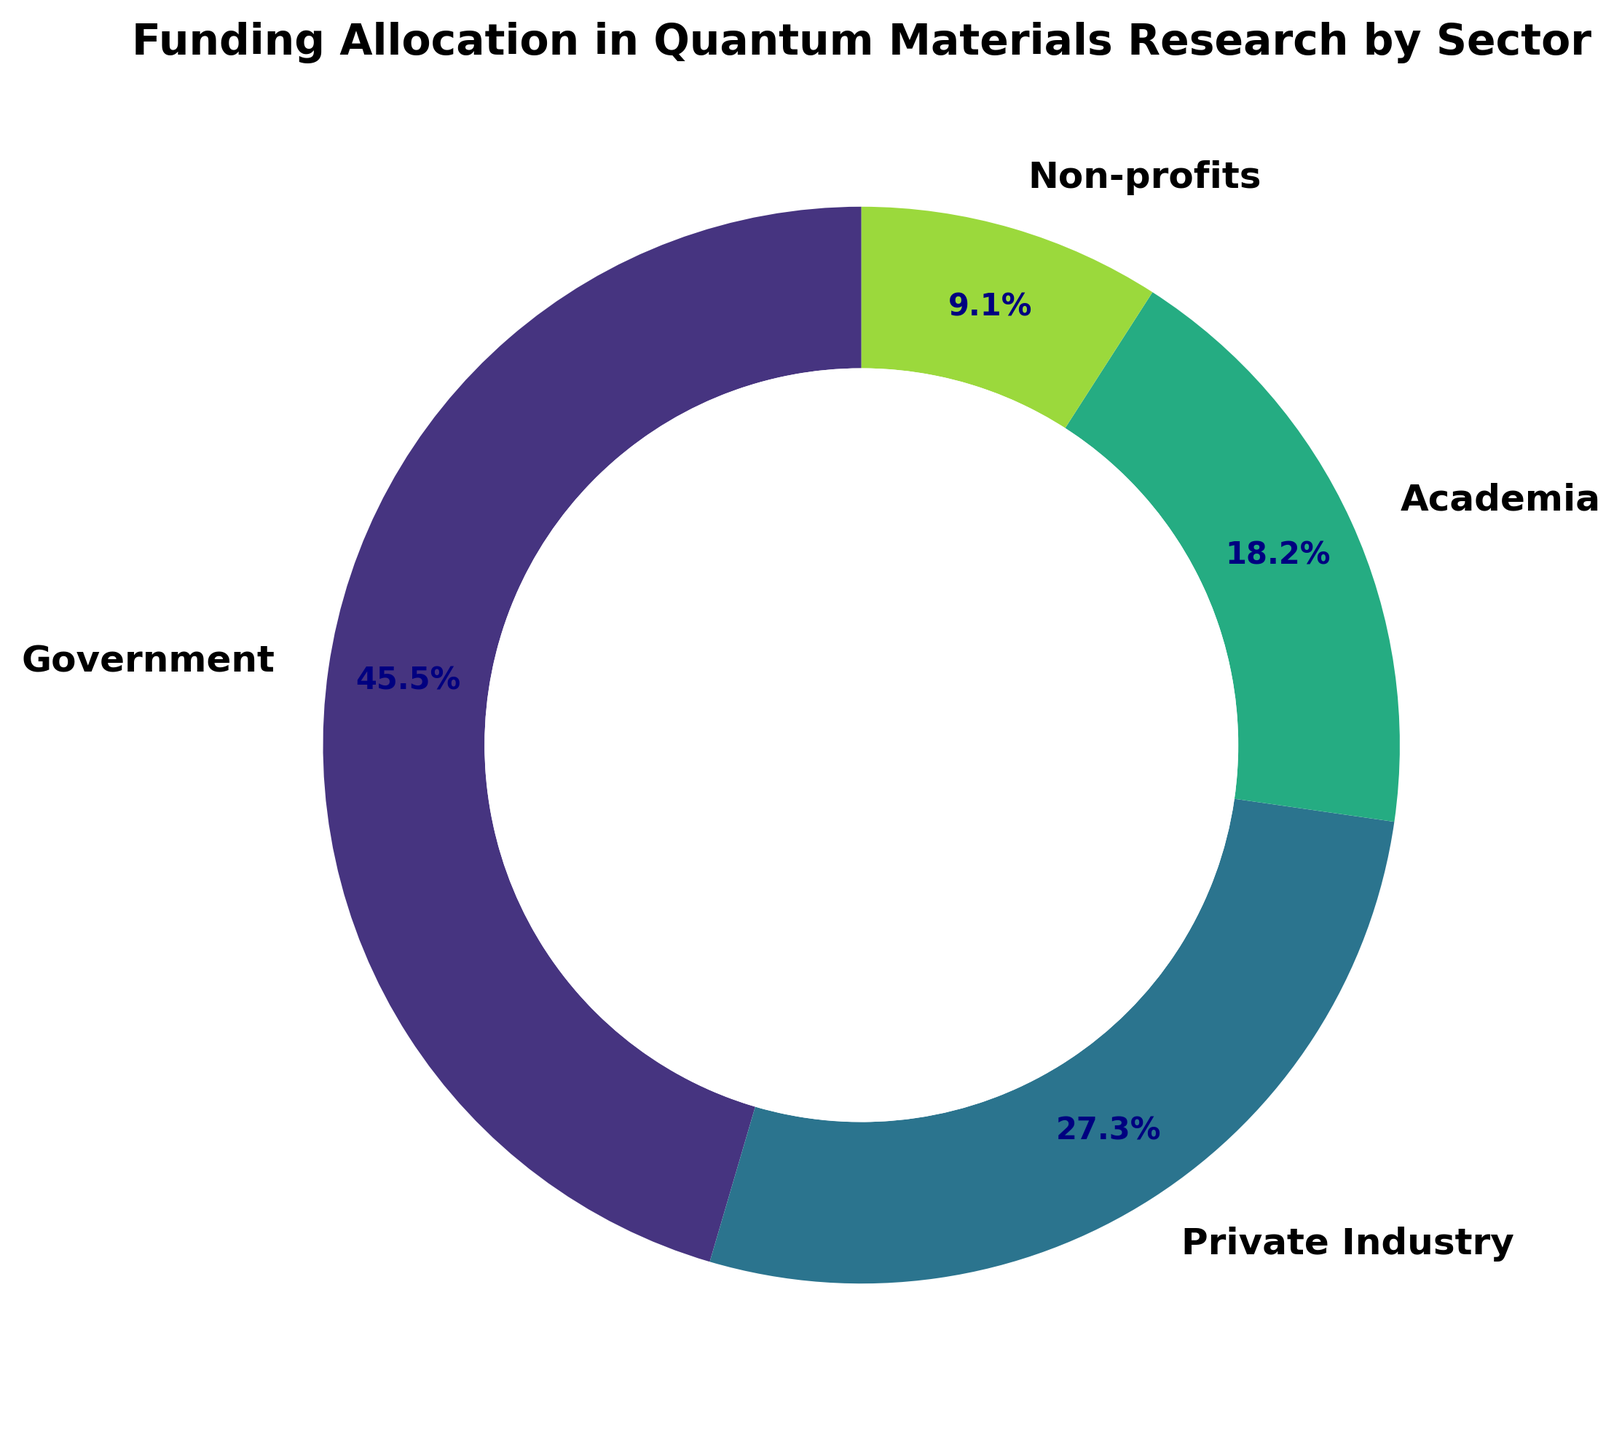Which sector receives the largest funding? The figure shows that the segment labeled "Government" is the largest in size and is annotated with the largest percentage, indicating it receives the largest funding amount.
Answer: Government How much more funding does the Government sector receive compared to the Private Industry sector? The funding for the Government sector is $250 million, and the funding for the Private Industry sector is $150 million. The difference is $250 million - $150 million = $100 million.
Answer: $100 million Which sector has the smallest funding allocation? The smallest segment in the figure is labeled "Non-profits" and annotated with the smallest percentage, indicating it receives the least funding.
Answer: Non-profits What is the combined funding for Academia and Non-profits? The funding for Academia is $100 million, and the funding for Non-profits is $50 million. The combined funding is $100 million + $50 million = $150 million.
Answer: $150 million Which sectors together make up more than half of the total funding? The Government sector accounts for 50%, so only one other sector needs to be included to exceed 50%. The Private Industry sector at 30% combines with the Government sector (50%) to make 80%, which is more than half.
Answer: Government and Private Industry Is the funding for Private Industry less than or equal to half of the total funding? The total funding is $550 million. Half of this is $275 million. The Private Industry sector has $150 million, which is less than $275 million.
Answer: Less than What percentage of the total funding goes to Academia and Non-profits combined? The funding for Academia is $100 million, and for Non-profits, it is $50 million. Their combined funding is $150 million. The total funding is $550 million. The percentage is ($150 million / $550 million) * 100 = 27.3%.
Answer: 27.3% Which two sectors have the closest funding amounts? The sectors with the closest funding amounts are Private Industry ($150 million) and Academia ($100 million).
Answer: Private Industry and Academia What proportion of the total funding does the Non-profits sector contribute? The funding for Non-profits is $50 million. The total funding is $550 million. The proportion is ($50 million / $550 million) * 100 = 9.1%.
Answer: 9.1% If the funding for Private Industry were doubled, would it surpass the Government sector's funding? The current funding for Private Industry is $150 million. If doubled, it would be $150 million * 2 = $300 million. The Government sector's funding is $250 million, so $300 million > $250 million.
Answer: Yes 